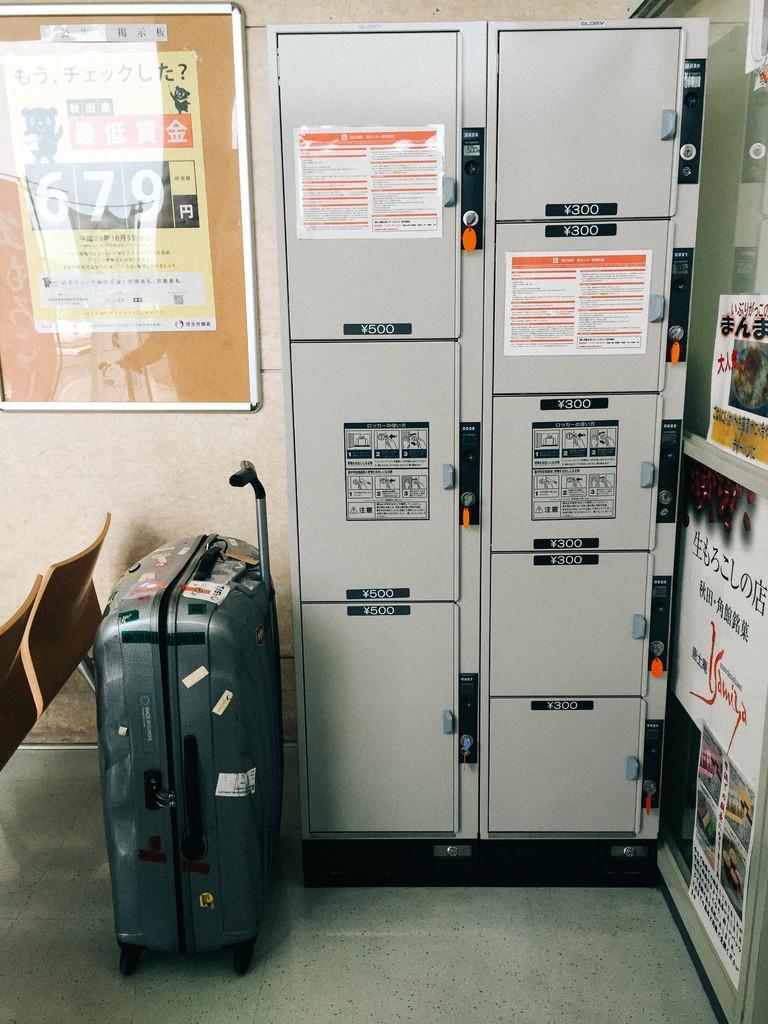How would you summarize this image in a sentence or two? In this image, there is a power panel on the right side of the image. There is a trolley and chairs on the left side of the image. 